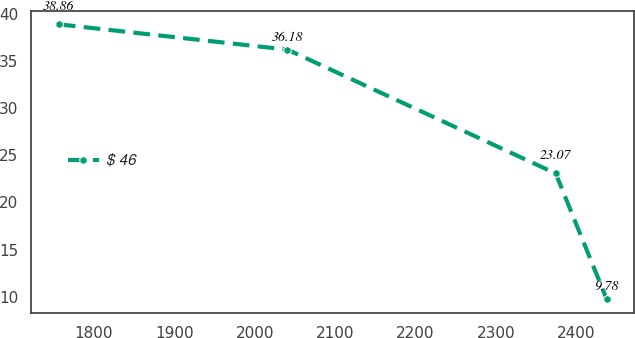Convert chart to OTSL. <chart><loc_0><loc_0><loc_500><loc_500><line_chart><ecel><fcel>$ 46<nl><fcel>1756.6<fcel>38.86<nl><fcel>2040.8<fcel>36.18<nl><fcel>2374.23<fcel>23.07<nl><fcel>2437.5<fcel>9.78<nl></chart> 